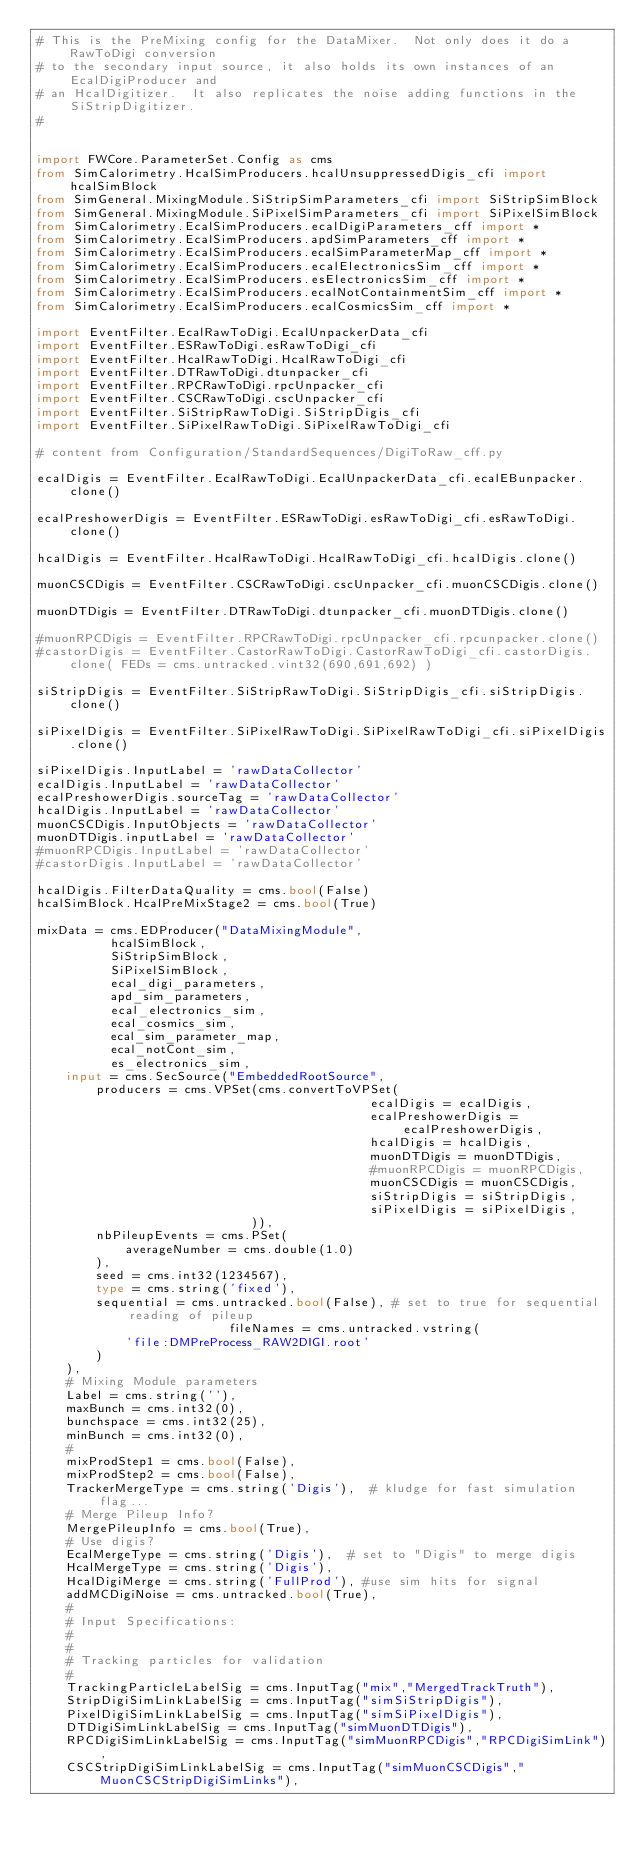Convert code to text. <code><loc_0><loc_0><loc_500><loc_500><_Python_># This is the PreMixing config for the DataMixer.  Not only does it do a RawToDigi conversion
# to the secondary input source, it also holds its own instances of an EcalDigiProducer and
# an HcalDigitizer.  It also replicates the noise adding functions in the SiStripDigitizer.
#


import FWCore.ParameterSet.Config as cms
from SimCalorimetry.HcalSimProducers.hcalUnsuppressedDigis_cfi import hcalSimBlock
from SimGeneral.MixingModule.SiStripSimParameters_cfi import SiStripSimBlock
from SimGeneral.MixingModule.SiPixelSimParameters_cfi import SiPixelSimBlock
from SimCalorimetry.EcalSimProducers.ecalDigiParameters_cff import *
from SimCalorimetry.EcalSimProducers.apdSimParameters_cff import *
from SimCalorimetry.EcalSimProducers.ecalSimParameterMap_cff import *
from SimCalorimetry.EcalSimProducers.ecalElectronicsSim_cff import *
from SimCalorimetry.EcalSimProducers.esElectronicsSim_cff import *
from SimCalorimetry.EcalSimProducers.ecalNotContainmentSim_cff import *
from SimCalorimetry.EcalSimProducers.ecalCosmicsSim_cff import *

import EventFilter.EcalRawToDigi.EcalUnpackerData_cfi
import EventFilter.ESRawToDigi.esRawToDigi_cfi
import EventFilter.HcalRawToDigi.HcalRawToDigi_cfi
import EventFilter.DTRawToDigi.dtunpacker_cfi
import EventFilter.RPCRawToDigi.rpcUnpacker_cfi
import EventFilter.CSCRawToDigi.cscUnpacker_cfi
import EventFilter.SiStripRawToDigi.SiStripDigis_cfi
import EventFilter.SiPixelRawToDigi.SiPixelRawToDigi_cfi

# content from Configuration/StandardSequences/DigiToRaw_cff.py

ecalDigis = EventFilter.EcalRawToDigi.EcalUnpackerData_cfi.ecalEBunpacker.clone()

ecalPreshowerDigis = EventFilter.ESRawToDigi.esRawToDigi_cfi.esRawToDigi.clone()

hcalDigis = EventFilter.HcalRawToDigi.HcalRawToDigi_cfi.hcalDigis.clone()

muonCSCDigis = EventFilter.CSCRawToDigi.cscUnpacker_cfi.muonCSCDigis.clone()

muonDTDigis = EventFilter.DTRawToDigi.dtunpacker_cfi.muonDTDigis.clone()

#muonRPCDigis = EventFilter.RPCRawToDigi.rpcUnpacker_cfi.rpcunpacker.clone()
#castorDigis = EventFilter.CastorRawToDigi.CastorRawToDigi_cfi.castorDigis.clone( FEDs = cms.untracked.vint32(690,691,692) )

siStripDigis = EventFilter.SiStripRawToDigi.SiStripDigis_cfi.siStripDigis.clone()

siPixelDigis = EventFilter.SiPixelRawToDigi.SiPixelRawToDigi_cfi.siPixelDigis.clone()

siPixelDigis.InputLabel = 'rawDataCollector'
ecalDigis.InputLabel = 'rawDataCollector'
ecalPreshowerDigis.sourceTag = 'rawDataCollector'
hcalDigis.InputLabel = 'rawDataCollector'
muonCSCDigis.InputObjects = 'rawDataCollector'
muonDTDigis.inputLabel = 'rawDataCollector'
#muonRPCDigis.InputLabel = 'rawDataCollector'
#castorDigis.InputLabel = 'rawDataCollector'

hcalDigis.FilterDataQuality = cms.bool(False)
hcalSimBlock.HcalPreMixStage2 = cms.bool(True)

mixData = cms.EDProducer("DataMixingModule",
          hcalSimBlock,
          SiStripSimBlock,
          SiPixelSimBlock,
          ecal_digi_parameters,
          apd_sim_parameters,
          ecal_electronics_sim,
          ecal_cosmics_sim,
          ecal_sim_parameter_map,
          ecal_notCont_sim,
          es_electronics_sim,
    input = cms.SecSource("EmbeddedRootSource",
        producers = cms.VPSet(cms.convertToVPSet(
                                             ecalDigis = ecalDigis,
                                             ecalPreshowerDigis = ecalPreshowerDigis,
                                             hcalDigis = hcalDigis,
                                             muonDTDigis = muonDTDigis,
                                             #muonRPCDigis = muonRPCDigis,
                                             muonCSCDigis = muonCSCDigis,
                                             siStripDigis = siStripDigis,
                                             siPixelDigis = siPixelDigis,
                             )),
        nbPileupEvents = cms.PSet(
            averageNumber = cms.double(1.0)
        ),
        seed = cms.int32(1234567),
        type = cms.string('fixed'),
        sequential = cms.untracked.bool(False), # set to true for sequential reading of pileup
                          fileNames = cms.untracked.vstring(
            'file:DMPreProcess_RAW2DIGI.root'
        )
    ),
    # Mixing Module parameters
    Label = cms.string(''),
    maxBunch = cms.int32(0),
    bunchspace = cms.int32(25),
    minBunch = cms.int32(0),
    #
    mixProdStep1 = cms.bool(False),
    mixProdStep2 = cms.bool(False),
    TrackerMergeType = cms.string('Digis'),  # kludge for fast simulation flag...
    # Merge Pileup Info?
    MergePileupInfo = cms.bool(True),                         
    # Use digis?               
    EcalMergeType = cms.string('Digis'),  # set to "Digis" to merge digis
    HcalMergeType = cms.string('Digis'),
    HcalDigiMerge = cms.string('FullProd'), #use sim hits for signal
    addMCDigiNoise = cms.untracked.bool(True),
    #
    # Input Specifications:
    #
    #
    # Tracking particles for validation
    #
    TrackingParticleLabelSig = cms.InputTag("mix","MergedTrackTruth"),
    StripDigiSimLinkLabelSig = cms.InputTag("simSiStripDigis"),
    PixelDigiSimLinkLabelSig = cms.InputTag("simSiPixelDigis"),
    DTDigiSimLinkLabelSig = cms.InputTag("simMuonDTDigis"),
    RPCDigiSimLinkLabelSig = cms.InputTag("simMuonRPCDigis","RPCDigiSimLink"),
    CSCStripDigiSimLinkLabelSig = cms.InputTag("simMuonCSCDigis","MuonCSCStripDigiSimLinks"),</code> 